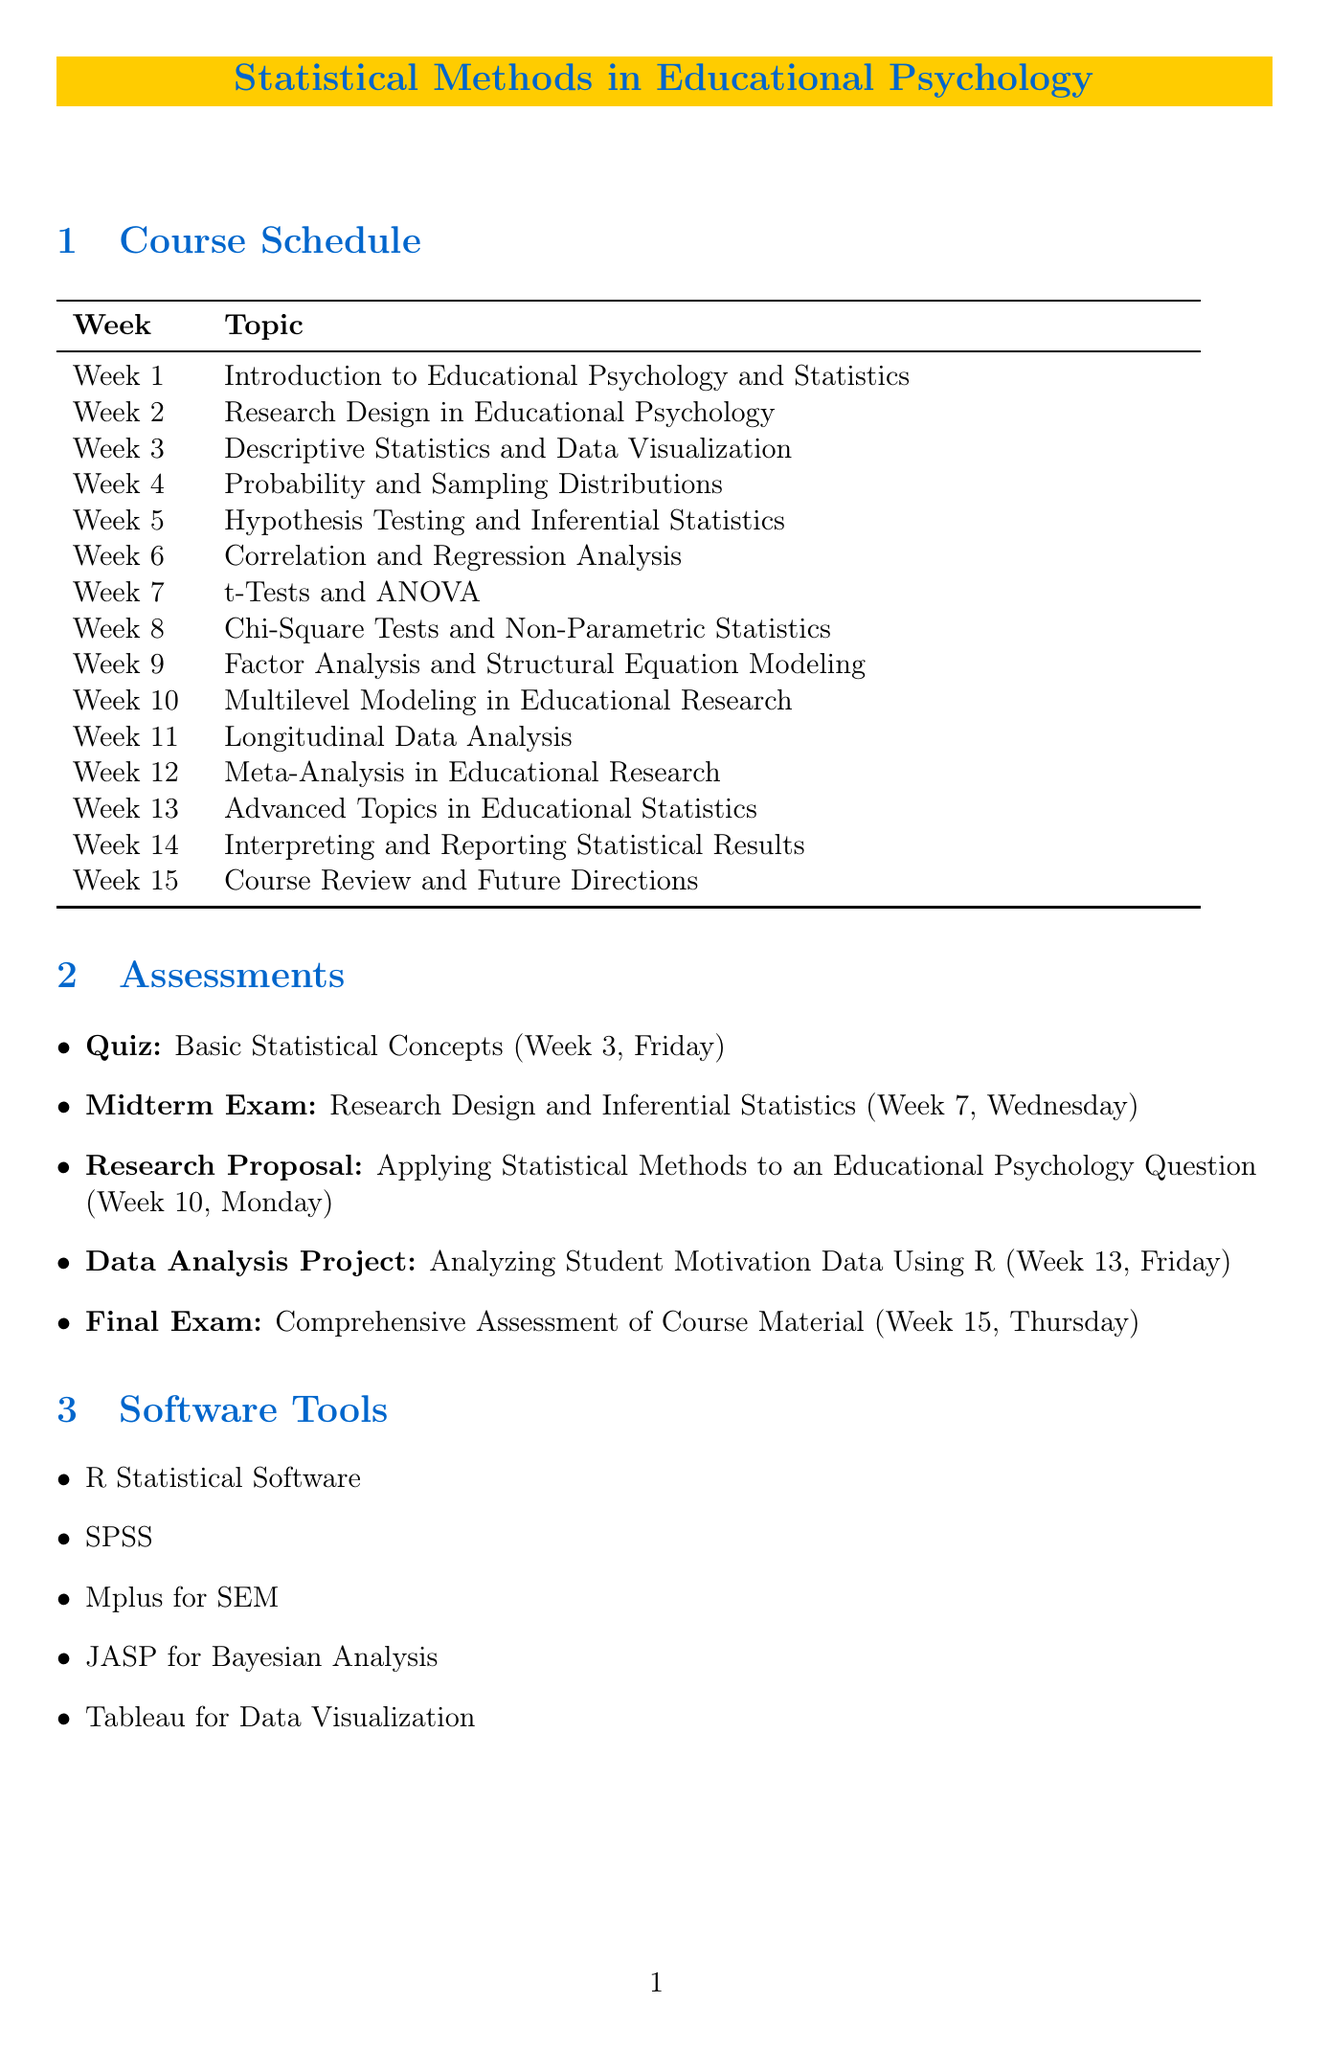What is the course title? The course title is explicitly mentioned in the header of the document.
Answer: Statistical Methods in Educational Psychology How many weeks does the semester last? The semester duration is indicated clearly in the document as the number of weeks.
Answer: 15 What is the topic of Week 5? The topic for Week 5 is directly provided in the course schedule section.
Answer: Hypothesis Testing and Inferential Statistics On which date is the Research Proposal due? The specific date of the Research Proposal assessment is noted in the assessments section.
Answer: Week 10, Monday Which software tool is recommended for Bayesian Analysis? The software tools section lists various tools, including the one for Bayesian Analysis explicitly.
Answer: JASP for Bayesian Analysis What kind of project is due in Week 13? The type of assessment due in Week 13 is described in the assessments section.
Answer: Data Analysis Project Which textbook focuses on structural equation modeling? The recommended textbooks provide the titles and authors, allowing us to identify the relevant book.
Answer: Principles and Practice of Structural Equation Modeling Which week features a quiz on basic statistical concepts? The assessments section clearly states the week and type of assessment related to basic statistical concepts.
Answer: Week 3 What statistical method is taught in Week 9? The topic for Week 9 is clearly specified in the course schedule.
Answer: Factor Analysis and Structural Equation Modeling 